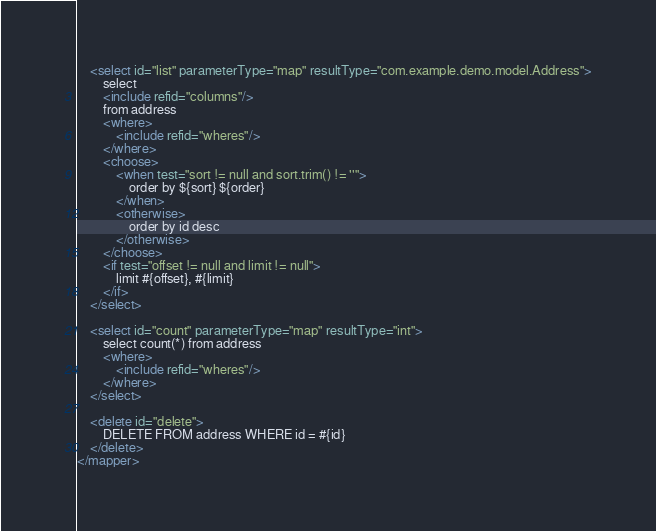Convert code to text. <code><loc_0><loc_0><loc_500><loc_500><_XML_>    <select id="list" parameterType="map" resultType="com.example.demo.model.Address">
        select
        <include refid="columns"/>
        from address
        <where>
            <include refid="wheres"/>
        </where>
        <choose>
            <when test="sort != null and sort.trim() != ''">
                order by ${sort} ${order}
            </when>
            <otherwise>
                order by id desc
            </otherwise>
        </choose>
        <if test="offset != null and limit != null">
            limit #{offset}, #{limit}
        </if>
    </select>

    <select id="count" parameterType="map" resultType="int">
        select count(*) from address
        <where>
            <include refid="wheres"/>
        </where>
    </select>

    <delete id="delete">
        DELETE FROM address WHERE id = #{id}
    </delete>
</mapper></code> 